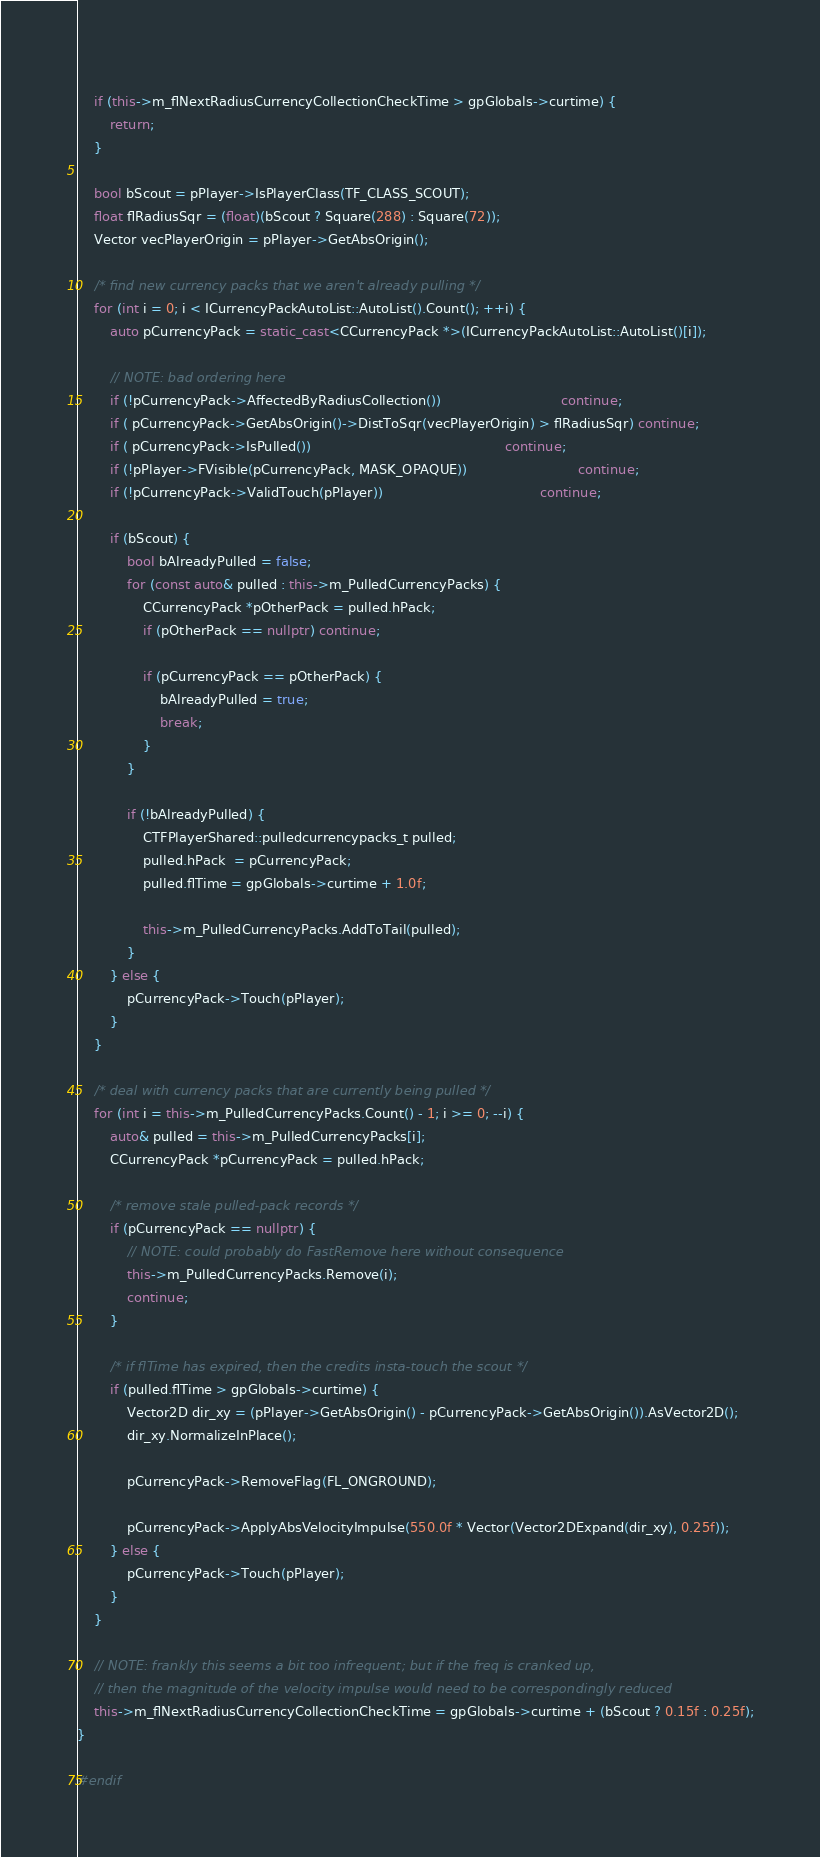<code> <loc_0><loc_0><loc_500><loc_500><_C++_>	
	if (this->m_flNextRadiusCurrencyCollectionCheckTime > gpGlobals->curtime) {
		return;
	}
	
	bool bScout = pPlayer->IsPlayerClass(TF_CLASS_SCOUT);
	float flRadiusSqr = (float)(bScout ? Square(288) : Square(72));
	Vector vecPlayerOrigin = pPlayer->GetAbsOrigin();
	
	/* find new currency packs that we aren't already pulling */
	for (int i = 0; i < ICurrencyPackAutoList::AutoList().Count(); ++i) {
		auto pCurrencyPack = static_cast<CCurrencyPack *>(ICurrencyPackAutoList::AutoList()[i]);
		
		// NOTE: bad ordering here
		if (!pCurrencyPack->AffectedByRadiusCollection())                             continue;
		if ( pCurrencyPack->GetAbsOrigin()->DistToSqr(vecPlayerOrigin) > flRadiusSqr) continue;
		if ( pCurrencyPack->IsPulled())                                               continue;
		if (!pPlayer->FVisible(pCurrencyPack, MASK_OPAQUE))                           continue;
		if (!pCurrencyPack->ValidTouch(pPlayer))                                      continue;
		
		if (bScout) {
			bool bAlreadyPulled = false;
			for (const auto& pulled : this->m_PulledCurrencyPacks) {
				CCurrencyPack *pOtherPack = pulled.hPack;
				if (pOtherPack == nullptr) continue;
				
				if (pCurrencyPack == pOtherPack) {
					bAlreadyPulled = true;
					break;
				}
			}
			
			if (!bAlreadyPulled) {
				CTFPlayerShared::pulledcurrencypacks_t pulled;
				pulled.hPack  = pCurrencyPack;
				pulled.flTime = gpGlobals->curtime + 1.0f;
				
				this->m_PulledCurrencyPacks.AddToTail(pulled);
			}
		} else {
			pCurrencyPack->Touch(pPlayer);
		}
	}
	
	/* deal with currency packs that are currently being pulled */
	for (int i = this->m_PulledCurrencyPacks.Count() - 1; i >= 0; --i) {
		auto& pulled = this->m_PulledCurrencyPacks[i];
		CCurrencyPack *pCurrencyPack = pulled.hPack;
		
		/* remove stale pulled-pack records */
		if (pCurrencyPack == nullptr) {
			// NOTE: could probably do FastRemove here without consequence
			this->m_PulledCurrencyPacks.Remove(i);
			continue;
		}
		
		/* if flTime has expired, then the credits insta-touch the scout */
		if (pulled.flTime > gpGlobals->curtime) {
			Vector2D dir_xy = (pPlayer->GetAbsOrigin() - pCurrencyPack->GetAbsOrigin()).AsVector2D();
			dir_xy.NormalizeInPlace();
			
			pCurrencyPack->RemoveFlag(FL_ONGROUND);
			
			pCurrencyPack->ApplyAbsVelocityImpulse(550.0f * Vector(Vector2DExpand(dir_xy), 0.25f));
		} else {
			pCurrencyPack->Touch(pPlayer);
		}
	}
	
	// NOTE: frankly this seems a bit too infrequent; but if the freq is cranked up,
	// then the magnitude of the velocity impulse would need to be correspondingly reduced
	this->m_flNextRadiusCurrencyCollectionCheckTime = gpGlobals->curtime + (bScout ? 0.15f : 0.25f);
}

#endif
</code> 